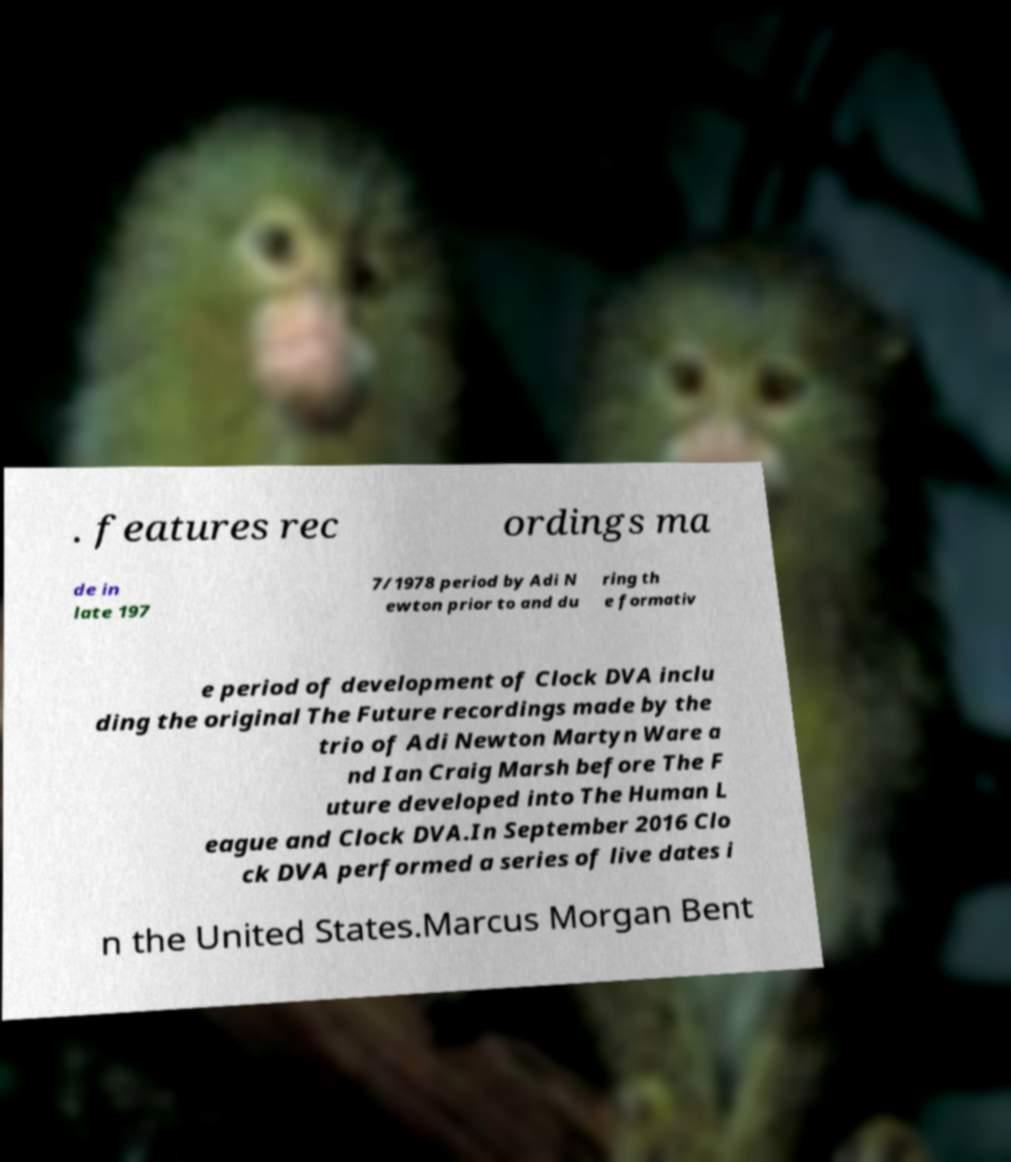Could you extract and type out the text from this image? . features rec ordings ma de in late 197 7/1978 period by Adi N ewton prior to and du ring th e formativ e period of development of Clock DVA inclu ding the original The Future recordings made by the trio of Adi Newton Martyn Ware a nd Ian Craig Marsh before The F uture developed into The Human L eague and Clock DVA.In September 2016 Clo ck DVA performed a series of live dates i n the United States.Marcus Morgan Bent 